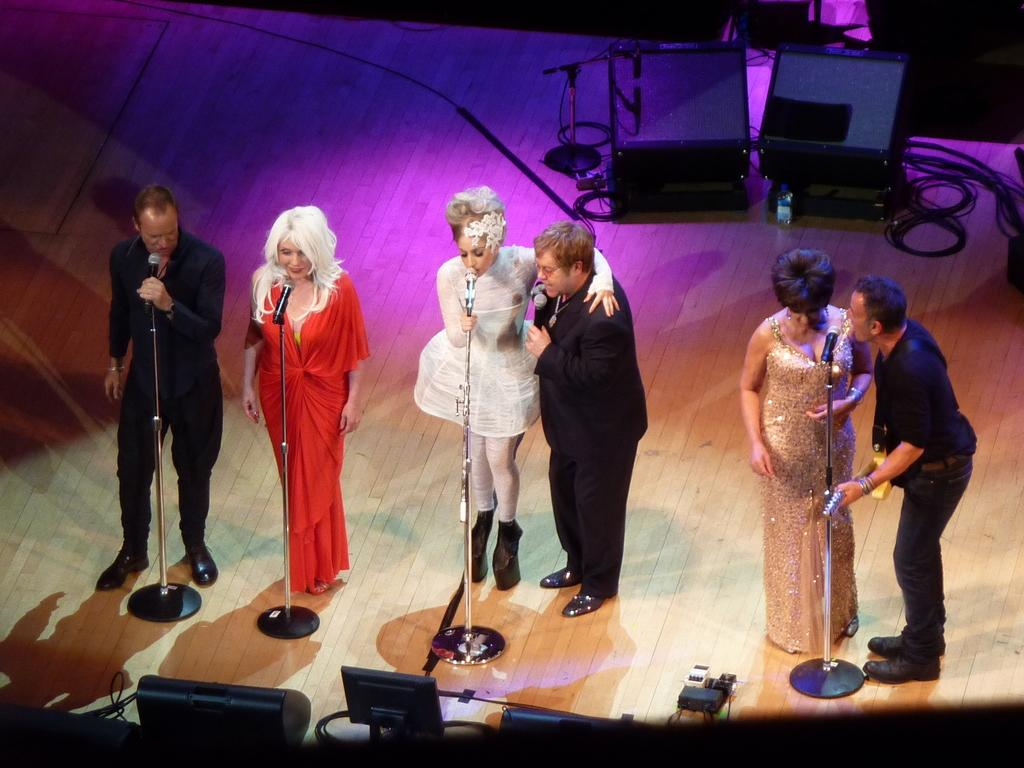What are the people on the stage doing? The persons on the stage are singing. What device is used by the singers to amplify their voices? There is a microphone (mic) in the image. What is used to project the sound to the audience? There are speakers in the image. What connects the microphone and speakers? There are wires in the image. What system is responsible for managing the sound during the performance? There is a sound system in the image. What can be inferred about the lighting conditions during the performance? The background appears to be dark. Can you see any wings on the persons singing on the stage? There are no wings visible on the persons singing on the stage in the image. What type of hill is present in the image? There is no hill present in the image; it features a stage with singers and equipment. 